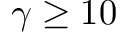Convert formula to latex. <formula><loc_0><loc_0><loc_500><loc_500>\gamma \geq 1 0</formula> 